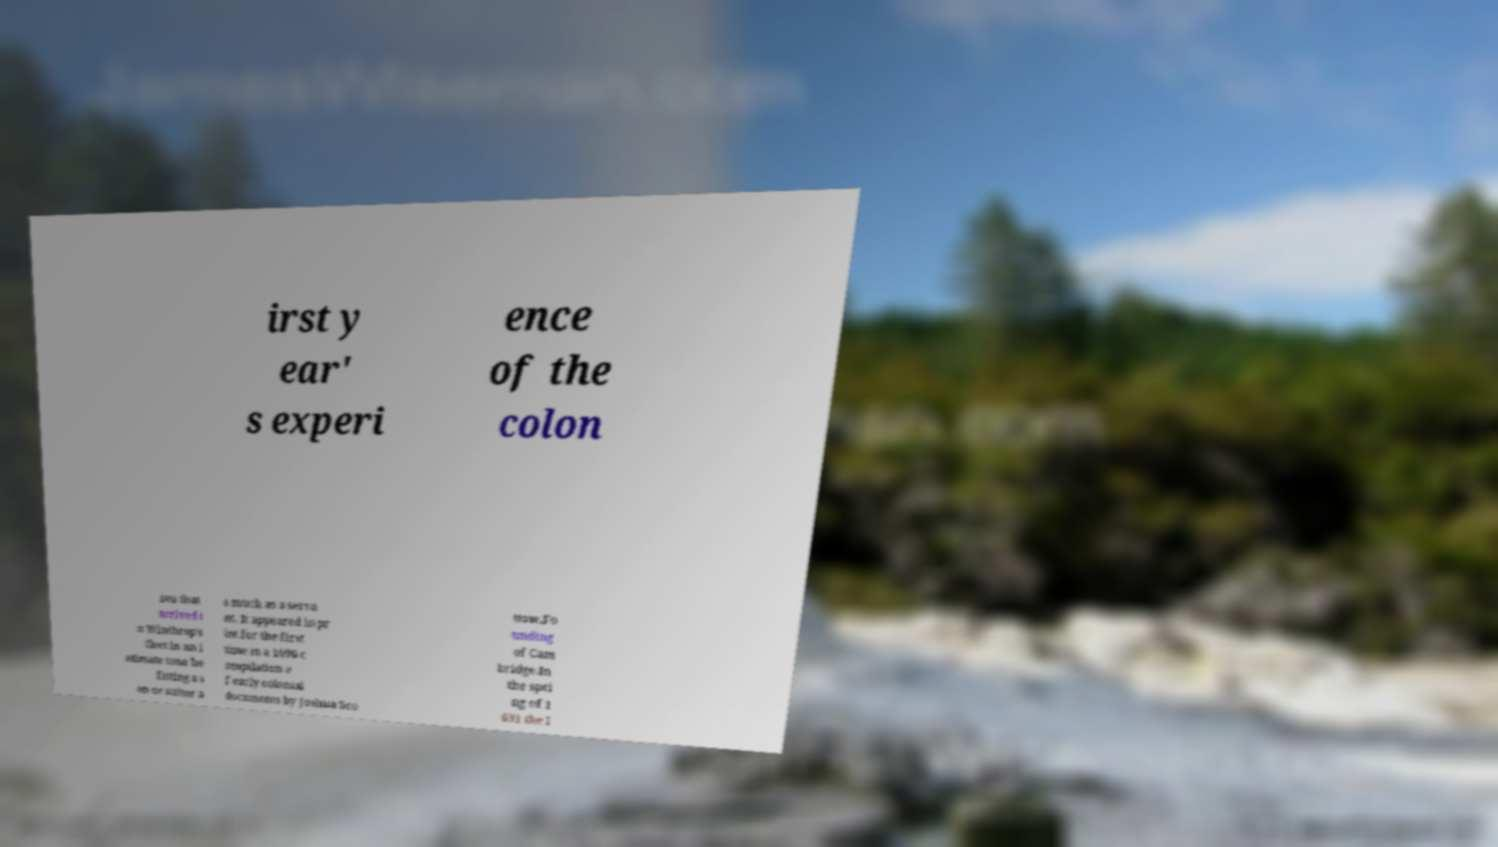I need the written content from this picture converted into text. Can you do that? irst y ear' s experi ence of the colon ists that arrived i n Winthrop's fleet in an i ntimate tone be fitting a s on or suitor a s much as a serva nt. It appeared in pr int for the first time in a 1696 c ompilation o f early colonial documents by Joshua Sco ttow.Fo unding of Cam bridge.In the spri ng of 1 631 the l 